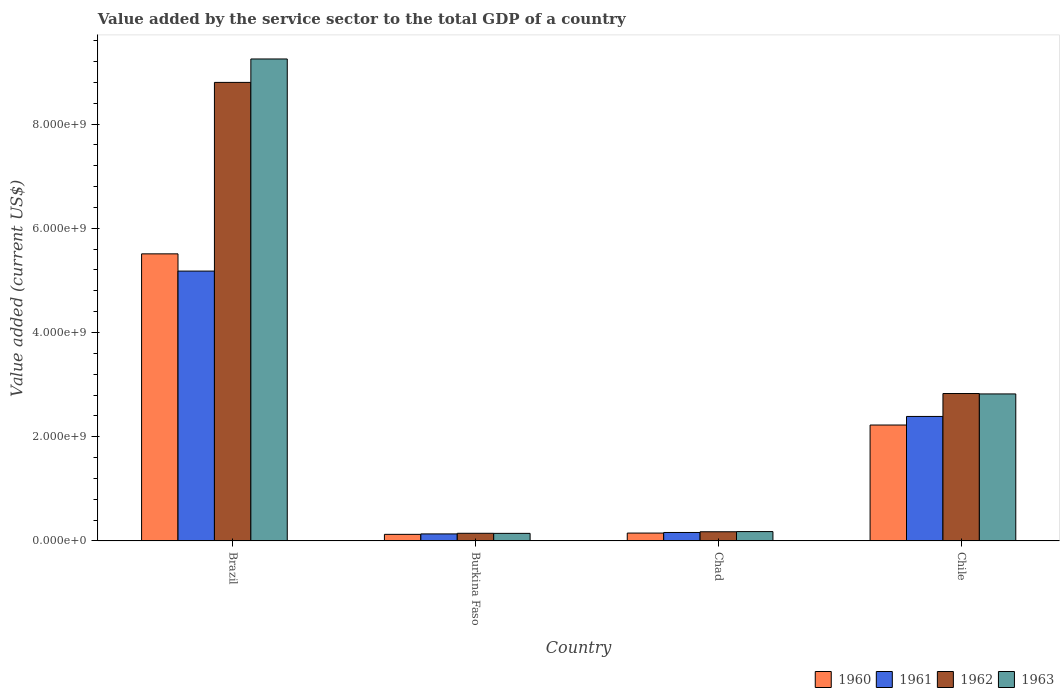How many different coloured bars are there?
Give a very brief answer. 4. How many groups of bars are there?
Offer a very short reply. 4. Are the number of bars on each tick of the X-axis equal?
Provide a short and direct response. Yes. How many bars are there on the 3rd tick from the left?
Provide a short and direct response. 4. What is the label of the 4th group of bars from the left?
Provide a succinct answer. Chile. What is the value added by the service sector to the total GDP in 1960 in Brazil?
Your response must be concise. 5.51e+09. Across all countries, what is the maximum value added by the service sector to the total GDP in 1960?
Your response must be concise. 5.51e+09. Across all countries, what is the minimum value added by the service sector to the total GDP in 1963?
Give a very brief answer. 1.45e+08. In which country was the value added by the service sector to the total GDP in 1962 minimum?
Make the answer very short. Burkina Faso. What is the total value added by the service sector to the total GDP in 1962 in the graph?
Provide a succinct answer. 1.20e+1. What is the difference between the value added by the service sector to the total GDP in 1963 in Burkina Faso and that in Chad?
Make the answer very short. -3.43e+07. What is the difference between the value added by the service sector to the total GDP in 1962 in Burkina Faso and the value added by the service sector to the total GDP in 1961 in Chad?
Keep it short and to the point. -1.58e+07. What is the average value added by the service sector to the total GDP in 1961 per country?
Your response must be concise. 1.97e+09. What is the difference between the value added by the service sector to the total GDP of/in 1963 and value added by the service sector to the total GDP of/in 1960 in Chad?
Make the answer very short. 2.87e+07. What is the ratio of the value added by the service sector to the total GDP in 1963 in Burkina Faso to that in Chad?
Your response must be concise. 0.81. Is the value added by the service sector to the total GDP in 1961 in Burkina Faso less than that in Chad?
Provide a succinct answer. Yes. What is the difference between the highest and the second highest value added by the service sector to the total GDP in 1960?
Ensure brevity in your answer.  5.36e+09. What is the difference between the highest and the lowest value added by the service sector to the total GDP in 1962?
Ensure brevity in your answer.  8.65e+09. Is it the case that in every country, the sum of the value added by the service sector to the total GDP in 1963 and value added by the service sector to the total GDP in 1960 is greater than the sum of value added by the service sector to the total GDP in 1961 and value added by the service sector to the total GDP in 1962?
Keep it short and to the point. No. Is it the case that in every country, the sum of the value added by the service sector to the total GDP in 1960 and value added by the service sector to the total GDP in 1962 is greater than the value added by the service sector to the total GDP in 1963?
Offer a very short reply. Yes. How many countries are there in the graph?
Offer a very short reply. 4. Are the values on the major ticks of Y-axis written in scientific E-notation?
Provide a succinct answer. Yes. Does the graph contain any zero values?
Your response must be concise. No. Where does the legend appear in the graph?
Your answer should be compact. Bottom right. What is the title of the graph?
Give a very brief answer. Value added by the service sector to the total GDP of a country. Does "2012" appear as one of the legend labels in the graph?
Offer a very short reply. No. What is the label or title of the X-axis?
Your response must be concise. Country. What is the label or title of the Y-axis?
Provide a short and direct response. Value added (current US$). What is the Value added (current US$) of 1960 in Brazil?
Your answer should be very brief. 5.51e+09. What is the Value added (current US$) of 1961 in Brazil?
Make the answer very short. 5.18e+09. What is the Value added (current US$) in 1962 in Brazil?
Make the answer very short. 8.80e+09. What is the Value added (current US$) in 1963 in Brazil?
Give a very brief answer. 9.25e+09. What is the Value added (current US$) in 1960 in Burkina Faso?
Provide a succinct answer. 1.26e+08. What is the Value added (current US$) of 1961 in Burkina Faso?
Provide a succinct answer. 1.35e+08. What is the Value added (current US$) of 1962 in Burkina Faso?
Give a very brief answer. 1.47e+08. What is the Value added (current US$) in 1963 in Burkina Faso?
Offer a terse response. 1.45e+08. What is the Value added (current US$) of 1960 in Chad?
Offer a very short reply. 1.51e+08. What is the Value added (current US$) of 1961 in Chad?
Provide a succinct answer. 1.62e+08. What is the Value added (current US$) in 1962 in Chad?
Keep it short and to the point. 1.76e+08. What is the Value added (current US$) in 1963 in Chad?
Keep it short and to the point. 1.80e+08. What is the Value added (current US$) of 1960 in Chile?
Offer a very short reply. 2.22e+09. What is the Value added (current US$) in 1961 in Chile?
Your answer should be very brief. 2.39e+09. What is the Value added (current US$) of 1962 in Chile?
Your answer should be very brief. 2.83e+09. What is the Value added (current US$) of 1963 in Chile?
Offer a very short reply. 2.82e+09. Across all countries, what is the maximum Value added (current US$) of 1960?
Give a very brief answer. 5.51e+09. Across all countries, what is the maximum Value added (current US$) in 1961?
Keep it short and to the point. 5.18e+09. Across all countries, what is the maximum Value added (current US$) in 1962?
Ensure brevity in your answer.  8.80e+09. Across all countries, what is the maximum Value added (current US$) in 1963?
Offer a very short reply. 9.25e+09. Across all countries, what is the minimum Value added (current US$) of 1960?
Make the answer very short. 1.26e+08. Across all countries, what is the minimum Value added (current US$) in 1961?
Ensure brevity in your answer.  1.35e+08. Across all countries, what is the minimum Value added (current US$) of 1962?
Provide a succinct answer. 1.47e+08. Across all countries, what is the minimum Value added (current US$) of 1963?
Give a very brief answer. 1.45e+08. What is the total Value added (current US$) of 1960 in the graph?
Make the answer very short. 8.01e+09. What is the total Value added (current US$) of 1961 in the graph?
Offer a very short reply. 7.86e+09. What is the total Value added (current US$) in 1962 in the graph?
Make the answer very short. 1.20e+1. What is the total Value added (current US$) in 1963 in the graph?
Provide a short and direct response. 1.24e+1. What is the difference between the Value added (current US$) in 1960 in Brazil and that in Burkina Faso?
Offer a terse response. 5.38e+09. What is the difference between the Value added (current US$) of 1961 in Brazil and that in Burkina Faso?
Provide a succinct answer. 5.04e+09. What is the difference between the Value added (current US$) of 1962 in Brazil and that in Burkina Faso?
Your response must be concise. 8.65e+09. What is the difference between the Value added (current US$) in 1963 in Brazil and that in Burkina Faso?
Make the answer very short. 9.10e+09. What is the difference between the Value added (current US$) of 1960 in Brazil and that in Chad?
Keep it short and to the point. 5.36e+09. What is the difference between the Value added (current US$) in 1961 in Brazil and that in Chad?
Offer a very short reply. 5.02e+09. What is the difference between the Value added (current US$) of 1962 in Brazil and that in Chad?
Ensure brevity in your answer.  8.62e+09. What is the difference between the Value added (current US$) in 1963 in Brazil and that in Chad?
Your answer should be very brief. 9.07e+09. What is the difference between the Value added (current US$) in 1960 in Brazil and that in Chile?
Give a very brief answer. 3.28e+09. What is the difference between the Value added (current US$) in 1961 in Brazil and that in Chile?
Ensure brevity in your answer.  2.79e+09. What is the difference between the Value added (current US$) in 1962 in Brazil and that in Chile?
Your answer should be compact. 5.97e+09. What is the difference between the Value added (current US$) of 1963 in Brazil and that in Chile?
Your answer should be very brief. 6.43e+09. What is the difference between the Value added (current US$) of 1960 in Burkina Faso and that in Chad?
Your answer should be compact. -2.45e+07. What is the difference between the Value added (current US$) in 1961 in Burkina Faso and that in Chad?
Your answer should be very brief. -2.77e+07. What is the difference between the Value added (current US$) of 1962 in Burkina Faso and that in Chad?
Offer a very short reply. -2.96e+07. What is the difference between the Value added (current US$) of 1963 in Burkina Faso and that in Chad?
Your answer should be compact. -3.43e+07. What is the difference between the Value added (current US$) in 1960 in Burkina Faso and that in Chile?
Give a very brief answer. -2.10e+09. What is the difference between the Value added (current US$) of 1961 in Burkina Faso and that in Chile?
Give a very brief answer. -2.25e+09. What is the difference between the Value added (current US$) of 1962 in Burkina Faso and that in Chile?
Provide a succinct answer. -2.68e+09. What is the difference between the Value added (current US$) of 1963 in Burkina Faso and that in Chile?
Keep it short and to the point. -2.68e+09. What is the difference between the Value added (current US$) of 1960 in Chad and that in Chile?
Offer a very short reply. -2.07e+09. What is the difference between the Value added (current US$) of 1961 in Chad and that in Chile?
Provide a short and direct response. -2.23e+09. What is the difference between the Value added (current US$) in 1962 in Chad and that in Chile?
Offer a very short reply. -2.65e+09. What is the difference between the Value added (current US$) in 1963 in Chad and that in Chile?
Provide a succinct answer. -2.64e+09. What is the difference between the Value added (current US$) of 1960 in Brazil and the Value added (current US$) of 1961 in Burkina Faso?
Your answer should be compact. 5.37e+09. What is the difference between the Value added (current US$) in 1960 in Brazil and the Value added (current US$) in 1962 in Burkina Faso?
Offer a terse response. 5.36e+09. What is the difference between the Value added (current US$) in 1960 in Brazil and the Value added (current US$) in 1963 in Burkina Faso?
Your response must be concise. 5.36e+09. What is the difference between the Value added (current US$) in 1961 in Brazil and the Value added (current US$) in 1962 in Burkina Faso?
Offer a very short reply. 5.03e+09. What is the difference between the Value added (current US$) in 1961 in Brazil and the Value added (current US$) in 1963 in Burkina Faso?
Offer a terse response. 5.03e+09. What is the difference between the Value added (current US$) of 1962 in Brazil and the Value added (current US$) of 1963 in Burkina Faso?
Your answer should be compact. 8.65e+09. What is the difference between the Value added (current US$) of 1960 in Brazil and the Value added (current US$) of 1961 in Chad?
Your answer should be compact. 5.35e+09. What is the difference between the Value added (current US$) in 1960 in Brazil and the Value added (current US$) in 1962 in Chad?
Ensure brevity in your answer.  5.33e+09. What is the difference between the Value added (current US$) in 1960 in Brazil and the Value added (current US$) in 1963 in Chad?
Keep it short and to the point. 5.33e+09. What is the difference between the Value added (current US$) of 1961 in Brazil and the Value added (current US$) of 1962 in Chad?
Offer a terse response. 5.00e+09. What is the difference between the Value added (current US$) of 1961 in Brazil and the Value added (current US$) of 1963 in Chad?
Make the answer very short. 5.00e+09. What is the difference between the Value added (current US$) of 1962 in Brazil and the Value added (current US$) of 1963 in Chad?
Offer a very short reply. 8.62e+09. What is the difference between the Value added (current US$) of 1960 in Brazil and the Value added (current US$) of 1961 in Chile?
Offer a very short reply. 3.12e+09. What is the difference between the Value added (current US$) in 1960 in Brazil and the Value added (current US$) in 1962 in Chile?
Your answer should be compact. 2.68e+09. What is the difference between the Value added (current US$) of 1960 in Brazil and the Value added (current US$) of 1963 in Chile?
Ensure brevity in your answer.  2.69e+09. What is the difference between the Value added (current US$) of 1961 in Brazil and the Value added (current US$) of 1962 in Chile?
Your answer should be compact. 2.35e+09. What is the difference between the Value added (current US$) in 1961 in Brazil and the Value added (current US$) in 1963 in Chile?
Keep it short and to the point. 2.36e+09. What is the difference between the Value added (current US$) of 1962 in Brazil and the Value added (current US$) of 1963 in Chile?
Your answer should be very brief. 5.98e+09. What is the difference between the Value added (current US$) of 1960 in Burkina Faso and the Value added (current US$) of 1961 in Chad?
Your answer should be very brief. -3.60e+07. What is the difference between the Value added (current US$) in 1960 in Burkina Faso and the Value added (current US$) in 1962 in Chad?
Provide a short and direct response. -4.98e+07. What is the difference between the Value added (current US$) in 1960 in Burkina Faso and the Value added (current US$) in 1963 in Chad?
Ensure brevity in your answer.  -5.32e+07. What is the difference between the Value added (current US$) of 1961 in Burkina Faso and the Value added (current US$) of 1962 in Chad?
Offer a terse response. -4.15e+07. What is the difference between the Value added (current US$) in 1961 in Burkina Faso and the Value added (current US$) in 1963 in Chad?
Offer a very short reply. -4.49e+07. What is the difference between the Value added (current US$) in 1962 in Burkina Faso and the Value added (current US$) in 1963 in Chad?
Keep it short and to the point. -3.29e+07. What is the difference between the Value added (current US$) in 1960 in Burkina Faso and the Value added (current US$) in 1961 in Chile?
Provide a succinct answer. -2.26e+09. What is the difference between the Value added (current US$) of 1960 in Burkina Faso and the Value added (current US$) of 1962 in Chile?
Offer a very short reply. -2.70e+09. What is the difference between the Value added (current US$) of 1960 in Burkina Faso and the Value added (current US$) of 1963 in Chile?
Offer a terse response. -2.69e+09. What is the difference between the Value added (current US$) in 1961 in Burkina Faso and the Value added (current US$) in 1962 in Chile?
Offer a terse response. -2.69e+09. What is the difference between the Value added (current US$) of 1961 in Burkina Faso and the Value added (current US$) of 1963 in Chile?
Provide a succinct answer. -2.69e+09. What is the difference between the Value added (current US$) in 1962 in Burkina Faso and the Value added (current US$) in 1963 in Chile?
Give a very brief answer. -2.67e+09. What is the difference between the Value added (current US$) of 1960 in Chad and the Value added (current US$) of 1961 in Chile?
Your answer should be very brief. -2.24e+09. What is the difference between the Value added (current US$) of 1960 in Chad and the Value added (current US$) of 1962 in Chile?
Keep it short and to the point. -2.68e+09. What is the difference between the Value added (current US$) of 1960 in Chad and the Value added (current US$) of 1963 in Chile?
Ensure brevity in your answer.  -2.67e+09. What is the difference between the Value added (current US$) of 1961 in Chad and the Value added (current US$) of 1962 in Chile?
Your answer should be compact. -2.67e+09. What is the difference between the Value added (current US$) in 1961 in Chad and the Value added (current US$) in 1963 in Chile?
Make the answer very short. -2.66e+09. What is the difference between the Value added (current US$) in 1962 in Chad and the Value added (current US$) in 1963 in Chile?
Your response must be concise. -2.64e+09. What is the average Value added (current US$) in 1960 per country?
Provide a short and direct response. 2.00e+09. What is the average Value added (current US$) of 1961 per country?
Keep it short and to the point. 1.97e+09. What is the average Value added (current US$) of 1962 per country?
Keep it short and to the point. 2.99e+09. What is the average Value added (current US$) of 1963 per country?
Offer a terse response. 3.10e+09. What is the difference between the Value added (current US$) in 1960 and Value added (current US$) in 1961 in Brazil?
Offer a very short reply. 3.31e+08. What is the difference between the Value added (current US$) of 1960 and Value added (current US$) of 1962 in Brazil?
Your answer should be compact. -3.29e+09. What is the difference between the Value added (current US$) in 1960 and Value added (current US$) in 1963 in Brazil?
Your answer should be compact. -3.74e+09. What is the difference between the Value added (current US$) of 1961 and Value added (current US$) of 1962 in Brazil?
Offer a very short reply. -3.62e+09. What is the difference between the Value added (current US$) of 1961 and Value added (current US$) of 1963 in Brazil?
Your answer should be very brief. -4.07e+09. What is the difference between the Value added (current US$) in 1962 and Value added (current US$) in 1963 in Brazil?
Give a very brief answer. -4.49e+08. What is the difference between the Value added (current US$) in 1960 and Value added (current US$) in 1961 in Burkina Faso?
Ensure brevity in your answer.  -8.32e+06. What is the difference between the Value added (current US$) of 1960 and Value added (current US$) of 1962 in Burkina Faso?
Your answer should be very brief. -2.03e+07. What is the difference between the Value added (current US$) in 1960 and Value added (current US$) in 1963 in Burkina Faso?
Provide a succinct answer. -1.89e+07. What is the difference between the Value added (current US$) of 1961 and Value added (current US$) of 1962 in Burkina Faso?
Offer a very short reply. -1.19e+07. What is the difference between the Value added (current US$) in 1961 and Value added (current US$) in 1963 in Burkina Faso?
Offer a very short reply. -1.06e+07. What is the difference between the Value added (current US$) in 1962 and Value added (current US$) in 1963 in Burkina Faso?
Offer a very short reply. 1.38e+06. What is the difference between the Value added (current US$) of 1960 and Value added (current US$) of 1961 in Chad?
Provide a succinct answer. -1.15e+07. What is the difference between the Value added (current US$) in 1960 and Value added (current US$) in 1962 in Chad?
Your answer should be compact. -2.53e+07. What is the difference between the Value added (current US$) in 1960 and Value added (current US$) in 1963 in Chad?
Offer a terse response. -2.87e+07. What is the difference between the Value added (current US$) in 1961 and Value added (current US$) in 1962 in Chad?
Make the answer very short. -1.38e+07. What is the difference between the Value added (current US$) of 1961 and Value added (current US$) of 1963 in Chad?
Ensure brevity in your answer.  -1.71e+07. What is the difference between the Value added (current US$) of 1962 and Value added (current US$) of 1963 in Chad?
Give a very brief answer. -3.34e+06. What is the difference between the Value added (current US$) of 1960 and Value added (current US$) of 1961 in Chile?
Give a very brief answer. -1.64e+08. What is the difference between the Value added (current US$) in 1960 and Value added (current US$) in 1962 in Chile?
Make the answer very short. -6.04e+08. What is the difference between the Value added (current US$) in 1960 and Value added (current US$) in 1963 in Chile?
Ensure brevity in your answer.  -5.96e+08. What is the difference between the Value added (current US$) in 1961 and Value added (current US$) in 1962 in Chile?
Provide a short and direct response. -4.40e+08. What is the difference between the Value added (current US$) of 1961 and Value added (current US$) of 1963 in Chile?
Your answer should be very brief. -4.32e+08. What is the difference between the Value added (current US$) in 1962 and Value added (current US$) in 1963 in Chile?
Your response must be concise. 8.01e+06. What is the ratio of the Value added (current US$) in 1960 in Brazil to that in Burkina Faso?
Your answer should be compact. 43.57. What is the ratio of the Value added (current US$) in 1961 in Brazil to that in Burkina Faso?
Keep it short and to the point. 38.42. What is the ratio of the Value added (current US$) in 1962 in Brazil to that in Burkina Faso?
Offer a very short reply. 59.98. What is the ratio of the Value added (current US$) in 1963 in Brazil to that in Burkina Faso?
Provide a succinct answer. 63.64. What is the ratio of the Value added (current US$) of 1960 in Brazil to that in Chad?
Your response must be concise. 36.49. What is the ratio of the Value added (current US$) in 1961 in Brazil to that in Chad?
Your answer should be compact. 31.87. What is the ratio of the Value added (current US$) of 1962 in Brazil to that in Chad?
Keep it short and to the point. 49.91. What is the ratio of the Value added (current US$) of 1963 in Brazil to that in Chad?
Keep it short and to the point. 51.49. What is the ratio of the Value added (current US$) of 1960 in Brazil to that in Chile?
Your answer should be very brief. 2.48. What is the ratio of the Value added (current US$) in 1961 in Brazil to that in Chile?
Your answer should be very brief. 2.17. What is the ratio of the Value added (current US$) of 1962 in Brazil to that in Chile?
Give a very brief answer. 3.11. What is the ratio of the Value added (current US$) of 1963 in Brazil to that in Chile?
Give a very brief answer. 3.28. What is the ratio of the Value added (current US$) of 1960 in Burkina Faso to that in Chad?
Give a very brief answer. 0.84. What is the ratio of the Value added (current US$) of 1961 in Burkina Faso to that in Chad?
Make the answer very short. 0.83. What is the ratio of the Value added (current US$) in 1962 in Burkina Faso to that in Chad?
Ensure brevity in your answer.  0.83. What is the ratio of the Value added (current US$) in 1963 in Burkina Faso to that in Chad?
Keep it short and to the point. 0.81. What is the ratio of the Value added (current US$) in 1960 in Burkina Faso to that in Chile?
Ensure brevity in your answer.  0.06. What is the ratio of the Value added (current US$) of 1961 in Burkina Faso to that in Chile?
Provide a short and direct response. 0.06. What is the ratio of the Value added (current US$) of 1962 in Burkina Faso to that in Chile?
Make the answer very short. 0.05. What is the ratio of the Value added (current US$) of 1963 in Burkina Faso to that in Chile?
Your response must be concise. 0.05. What is the ratio of the Value added (current US$) of 1960 in Chad to that in Chile?
Keep it short and to the point. 0.07. What is the ratio of the Value added (current US$) of 1961 in Chad to that in Chile?
Ensure brevity in your answer.  0.07. What is the ratio of the Value added (current US$) in 1962 in Chad to that in Chile?
Make the answer very short. 0.06. What is the ratio of the Value added (current US$) in 1963 in Chad to that in Chile?
Offer a terse response. 0.06. What is the difference between the highest and the second highest Value added (current US$) of 1960?
Your response must be concise. 3.28e+09. What is the difference between the highest and the second highest Value added (current US$) in 1961?
Offer a terse response. 2.79e+09. What is the difference between the highest and the second highest Value added (current US$) of 1962?
Make the answer very short. 5.97e+09. What is the difference between the highest and the second highest Value added (current US$) in 1963?
Your answer should be very brief. 6.43e+09. What is the difference between the highest and the lowest Value added (current US$) in 1960?
Provide a short and direct response. 5.38e+09. What is the difference between the highest and the lowest Value added (current US$) of 1961?
Keep it short and to the point. 5.04e+09. What is the difference between the highest and the lowest Value added (current US$) of 1962?
Your answer should be compact. 8.65e+09. What is the difference between the highest and the lowest Value added (current US$) of 1963?
Provide a succinct answer. 9.10e+09. 